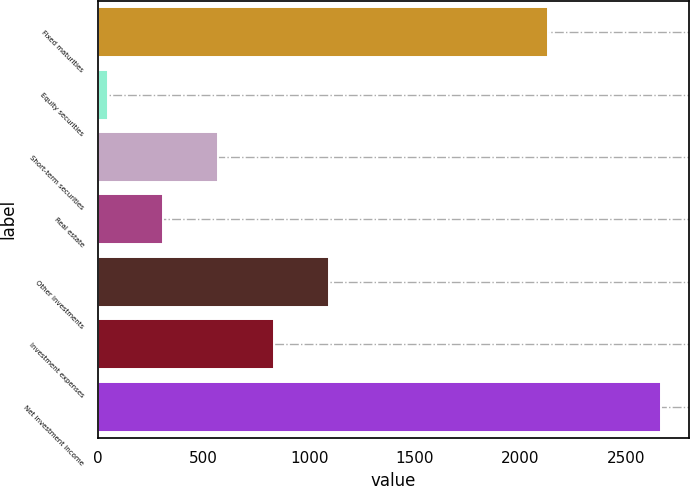Convert chart to OTSL. <chart><loc_0><loc_0><loc_500><loc_500><bar_chart><fcel>Fixed maturities<fcel>Equity securities<fcel>Short-term securities<fcel>Real estate<fcel>Other investments<fcel>Investment expenses<fcel>Net investment income<nl><fcel>2128<fcel>47<fcel>570.2<fcel>308.6<fcel>1093.4<fcel>831.8<fcel>2663<nl></chart> 